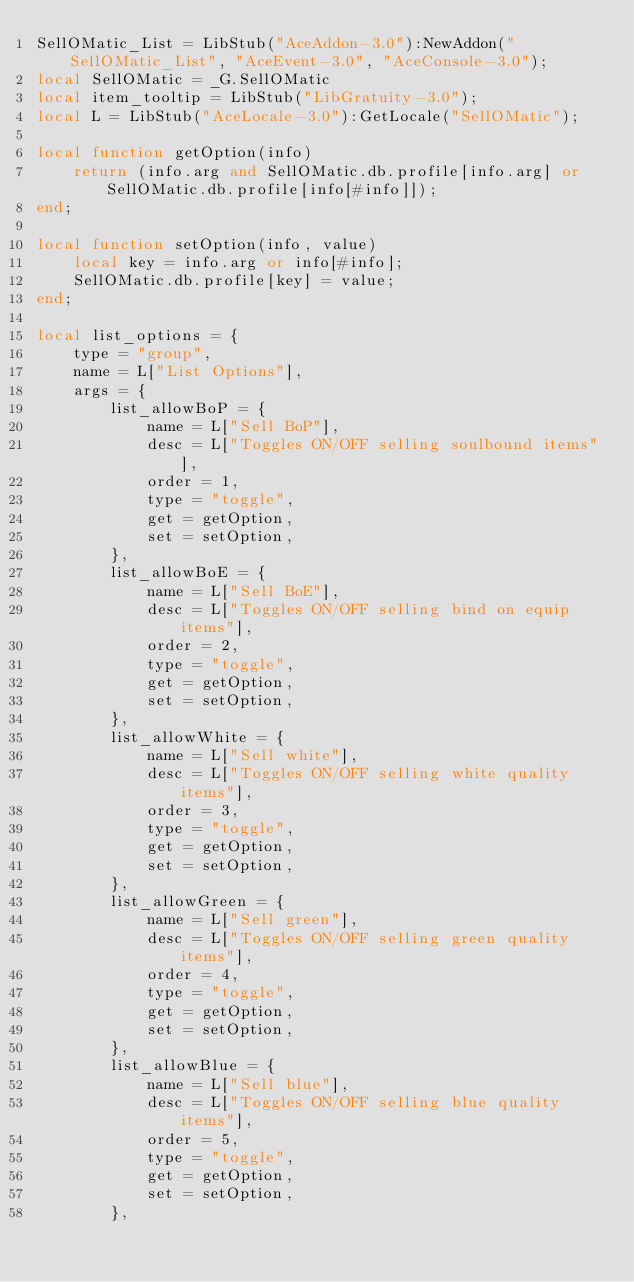Convert code to text. <code><loc_0><loc_0><loc_500><loc_500><_Lua_>SellOMatic_List = LibStub("AceAddon-3.0"):NewAddon("SellOMatic_List", "AceEvent-3.0", "AceConsole-3.0");
local SellOMatic = _G.SellOMatic
local item_tooltip = LibStub("LibGratuity-3.0");
local L = LibStub("AceLocale-3.0"):GetLocale("SellOMatic");

local function getOption(info)
	return (info.arg and SellOMatic.db.profile[info.arg] or SellOMatic.db.profile[info[#info]]);
end;

local function setOption(info, value)
	local key = info.arg or info[#info];
	SellOMatic.db.profile[key] = value;
end;

local list_options = {
	type = "group",
	name = L["List Options"],
	args = {
		list_allowBoP = {
			name = L["Sell BoP"],
			desc = L["Toggles ON/OFF selling soulbound items"],
			order = 1,
			type = "toggle",
			get = getOption,
			set = setOption,
		},
		list_allowBoE = {
			name = L["Sell BoE"],
			desc = L["Toggles ON/OFF selling bind on equip items"],
			order = 2,
			type = "toggle",
			get = getOption,
			set = setOption,
		},
		list_allowWhite = {
			name = L["Sell white"],
			desc = L["Toggles ON/OFF selling white quality items"],
			order = 3,
			type = "toggle",
			get = getOption,
			set = setOption,
		},
		list_allowGreen = {
			name = L["Sell green"],
			desc = L["Toggles ON/OFF selling green quality items"],
			order = 4,
			type = "toggle",
			get = getOption,
			set = setOption,
		},
		list_allowBlue = {
			name = L["Sell blue"],
			desc = L["Toggles ON/OFF selling blue quality items"],
			order = 5,
			type = "toggle",
			get = getOption,
			set = setOption,
		},</code> 